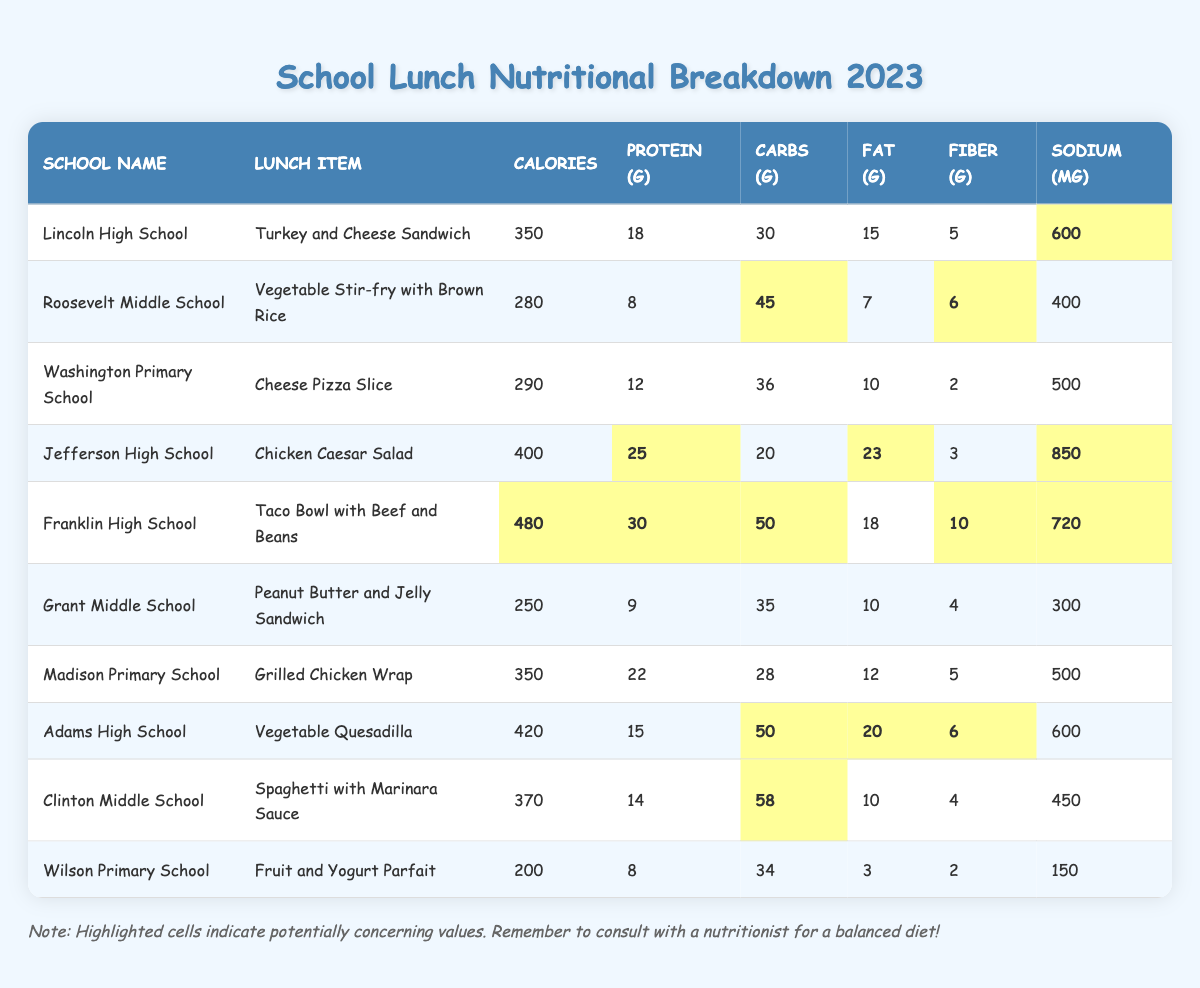What's the lunch item with the highest calorie count? The table lists calorie counts for each lunch item. Scanning through the values, the Taco Bowl with Beef and Beans from Franklin High School has the highest calorie count of 480.
Answer: Taco Bowl with Beef and Beans How much protein is in the Chicken Caesar Salad? The protein content for each lunch item is listed in the table. The Chicken Caesar Salad provides 25 grams of protein.
Answer: 25 grams Which school serves a Vegetable Stir-fry with the least sodium? The sodium levels for each lunch are provided, and the Vegetable Stir-fry from Roosevelt Middle School has 400 mg, which is lower than the others serving vegetables.
Answer: Roosevelt Middle School Calculate the average carbohydrates in the lunch items served. Adding all carbohydrate values (30 + 45 + 36 + 20 + 50 + 35 + 28 + 50 + 58 + 34 =  436) and dividing by the number of items (10), gives an average of 43.6 grams.
Answer: 43.6 grams Does the Fruit and Yogurt Parfait have more fiber than the Cheese Pizza Slice? The fiber content of the Fruit and Yogurt Parfait is 2 grams, while the Cheese Pizza Slice has 2 grams as well. Therefore, they have equal fiber content.
Answer: No What is the total fat content in the Taco Bowl with Beef and Beans? The table specifies the Taco Bowl with Beef and Beans lists 18 grams of fat.
Answer: 18 grams Which school’s lunch item contains the highest amount of sodium, and how much is it? Looking at the sodium values, Jefferson High School serves the Chicken Caesar Salad with the highest sodium content at 850 mg.
Answer: Jefferson High School, 850 mg What is the difference in calories between the Grilled Chicken Wrap and the Peanut Butter and Jelly Sandwich? The Grilled Chicken Wrap has 350 calories, while the Peanut Butter and Jelly Sandwich has 250 calories. The difference is 350 - 250 = 100 calories.
Answer: 100 calories Is the protein content of the Vegetable Quesadilla higher than the Turkey and Cheese Sandwich? The Vegetable Quesadilla has 15 grams of protein and the Turkey and Cheese Sandwich has 18 grams. This indicates that the Turkey and Cheese Sandwich has a higher protein content.
Answer: No Which school offers the lunch with the smallest calorie count? Scanning the calorie counts from each lunch item, the Peanut Butter and Jelly Sandwich from Grant Middle School has the lowest calorie count at 250 calories.
Answer: Grant Middle School 